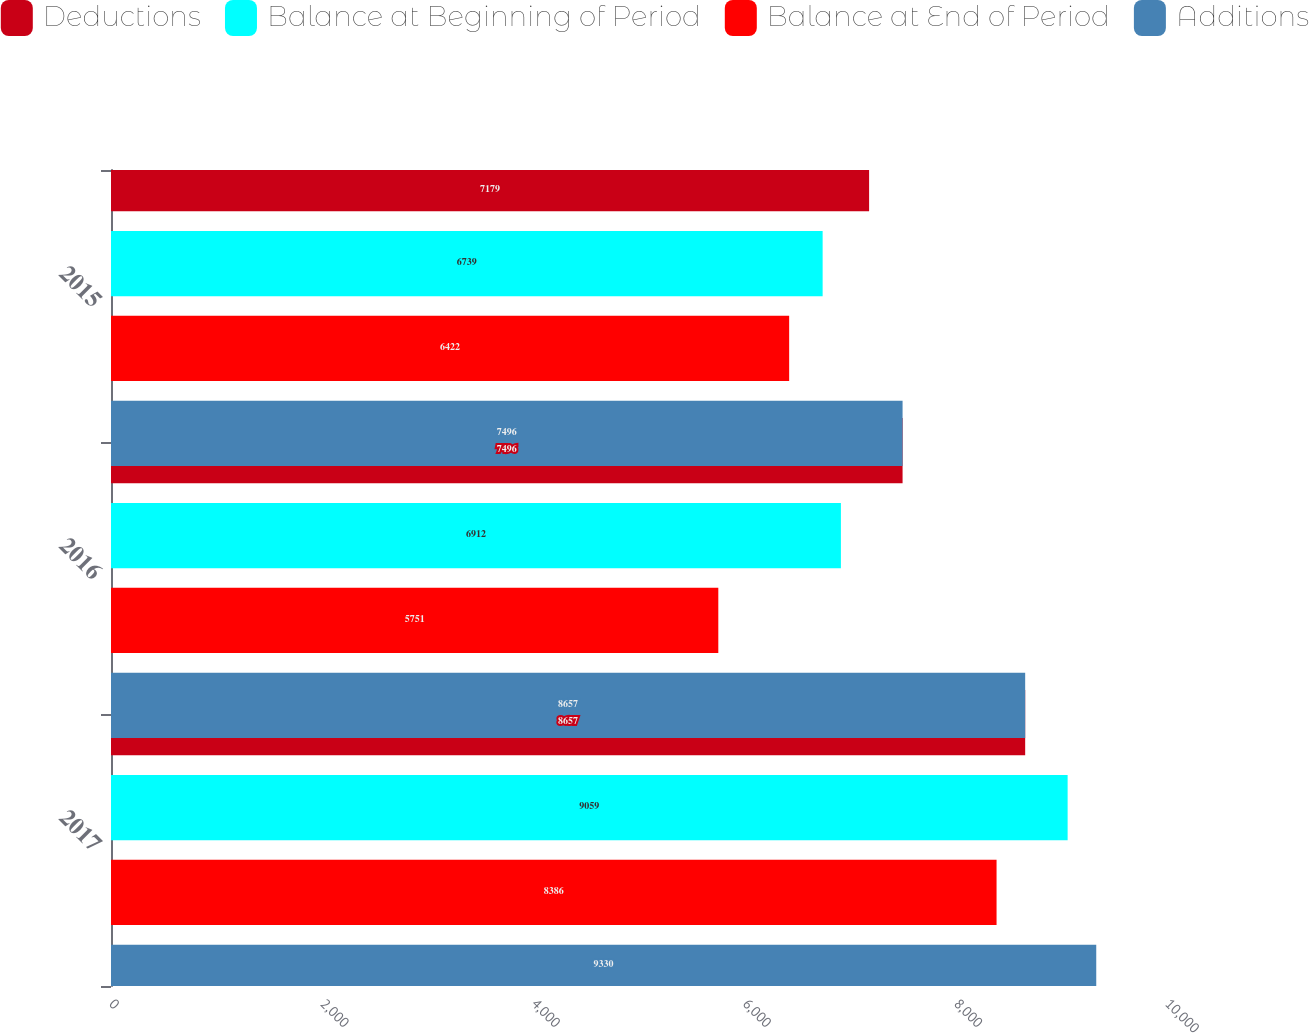<chart> <loc_0><loc_0><loc_500><loc_500><stacked_bar_chart><ecel><fcel>2017<fcel>2016<fcel>2015<nl><fcel>Deductions<fcel>8657<fcel>7496<fcel>7179<nl><fcel>Balance at Beginning of Period<fcel>9059<fcel>6912<fcel>6739<nl><fcel>Balance at End of Period<fcel>8386<fcel>5751<fcel>6422<nl><fcel>Additions<fcel>9330<fcel>8657<fcel>7496<nl></chart> 